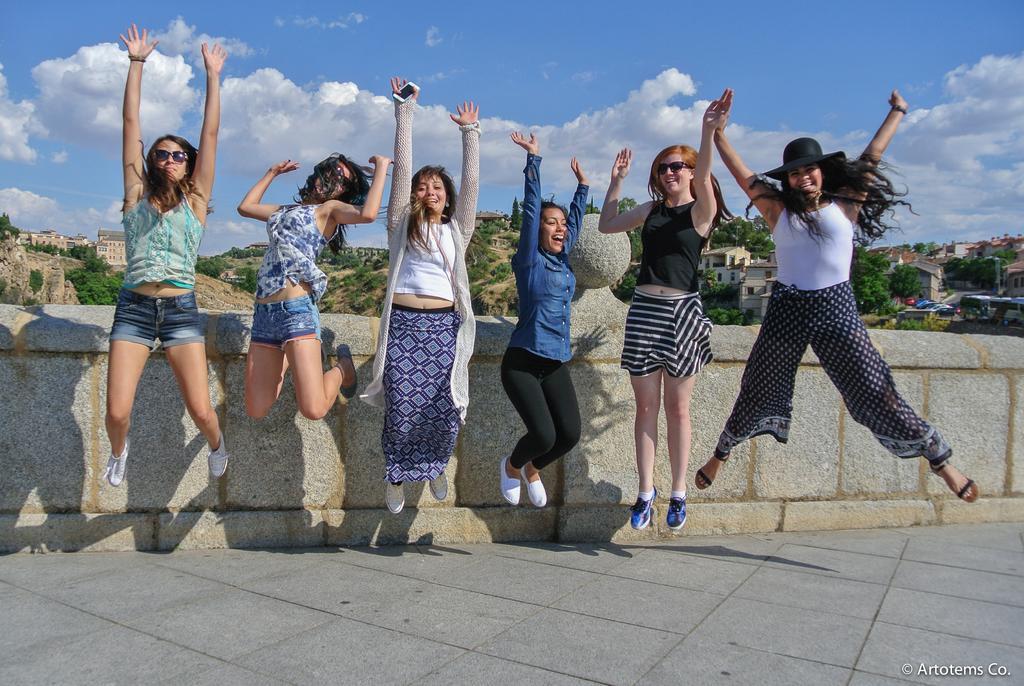In one or two sentences, can you explain what this image depicts? In this image we can see these women are in the air and smiling. In the background, we can see the stone wall, stone buildings on the hills, trees, vehicles moving on the road and the sky with clouds. Here we can see a watermark on the bottom right side of the image. 